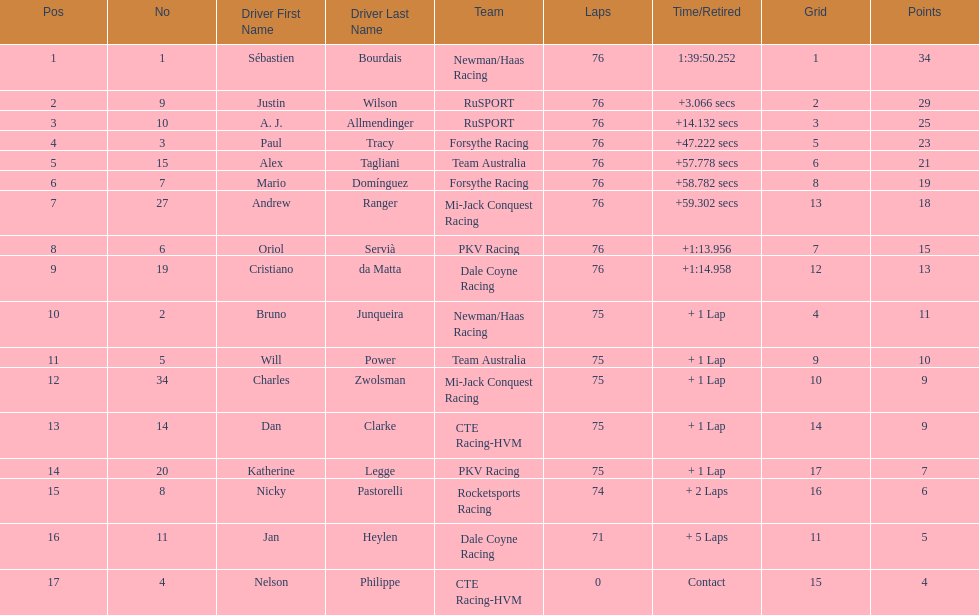Charles zwolsman acquired the same number of points as who? Dan Clarke. 